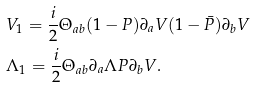<formula> <loc_0><loc_0><loc_500><loc_500>& V _ { 1 } = \frac { i } { 2 } \Theta _ { a b } ( 1 - P ) \partial _ { a } V ( 1 - \bar { P } ) \partial _ { b } V \\ & \Lambda _ { 1 } = \frac { i } { 2 } \Theta _ { a b } \partial _ { a } \Lambda P \partial _ { b } V .</formula> 